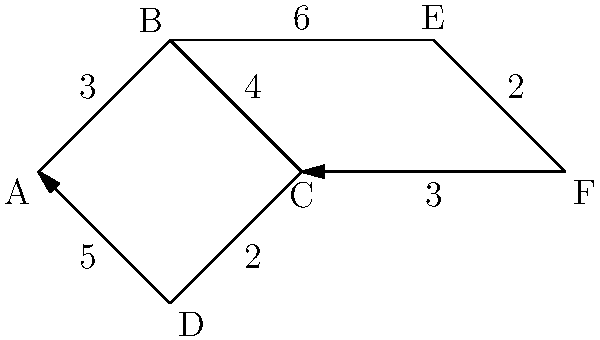As an agriculturist designing an efficient irrigation system for your farm, you need to determine the most cost-effective route to connect water sources. The network diagram represents different irrigation paths, where nodes are water sources or distribution points, and edge weights represent installation costs in thousands of dollars. What is the minimum cost (in thousands of dollars) to connect all points in the network? To find the minimum cost to connect all points in the network, we need to find the Minimum Spanning Tree (MST) of the given graph. We can use Kruskal's algorithm to solve this problem:

1. Sort all edges by weight in ascending order:
   (C,D): 2
   (E,F): 2
   (A,B): 3
   (C,F): 3
   (B,C): 4
   (A,D): 5
   (B,E): 6

2. Start with an empty MST and add edges in order, skipping those that would create a cycle:
   - Add (C,D): 2
   - Add (E,F): 2
   - Add (A,B): 3
   - Add (C,F): 3
   - Add (B,C): 4

3. At this point, all nodes are connected, and we have the MST.

4. Sum the weights of the edges in the MST:
   $2 + 2 + 3 + 3 + 4 = 14$

Therefore, the minimum cost to connect all points in the network is 14 thousand dollars.
Answer: $14,000 